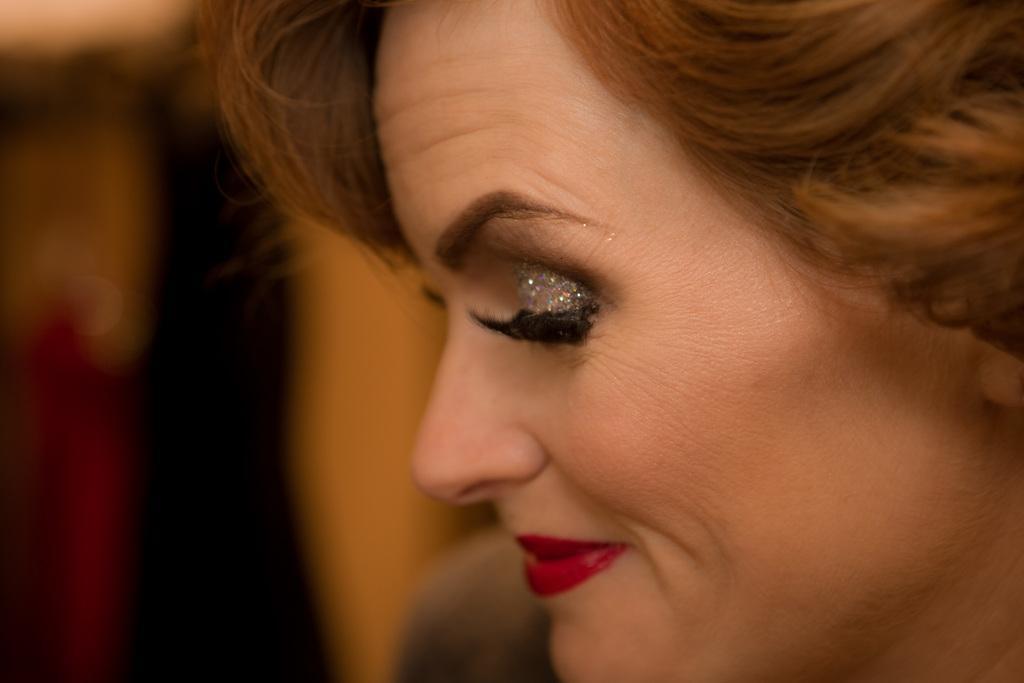Could you give a brief overview of what you see in this image? In this image we can see a lady with a glitter eyeshadow and the background is blurred. 